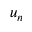<formula> <loc_0><loc_0><loc_500><loc_500>u _ { n }</formula> 